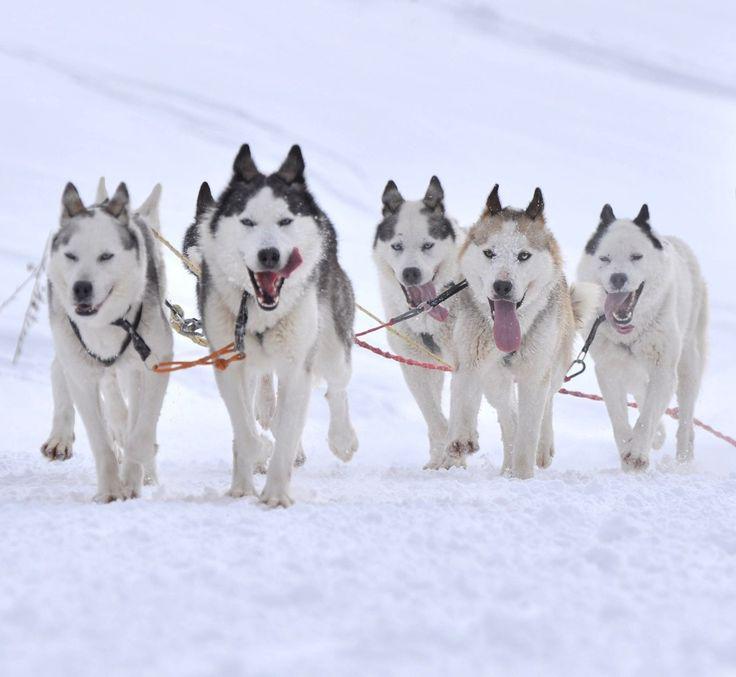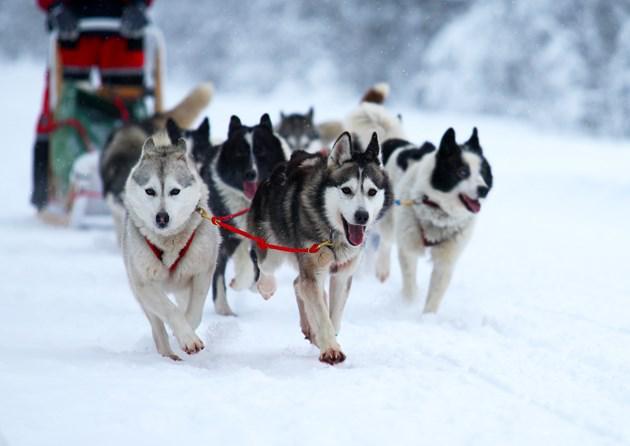The first image is the image on the left, the second image is the image on the right. For the images displayed, is the sentence "The right image contains no more than three dogs." factually correct? Answer yes or no. No. 